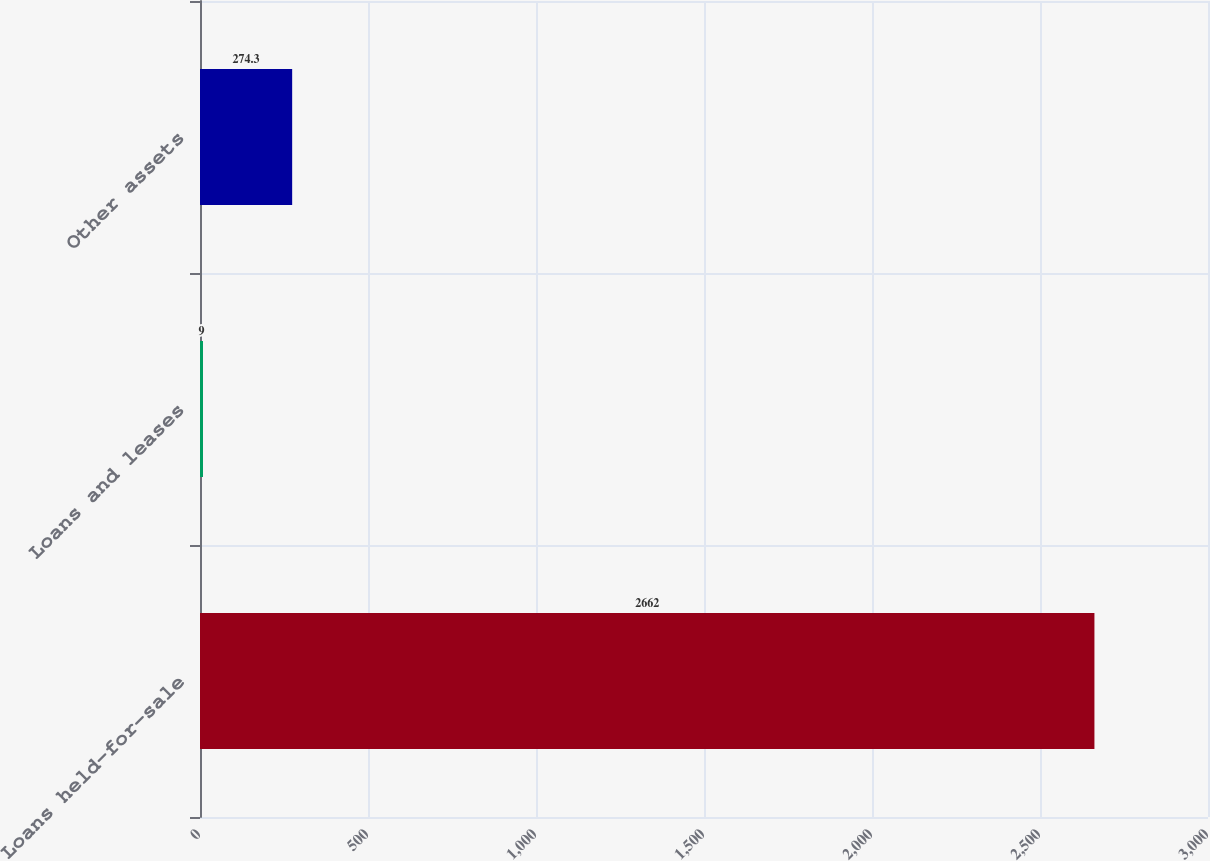Convert chart. <chart><loc_0><loc_0><loc_500><loc_500><bar_chart><fcel>Loans held-for-sale<fcel>Loans and leases<fcel>Other assets<nl><fcel>2662<fcel>9<fcel>274.3<nl></chart> 